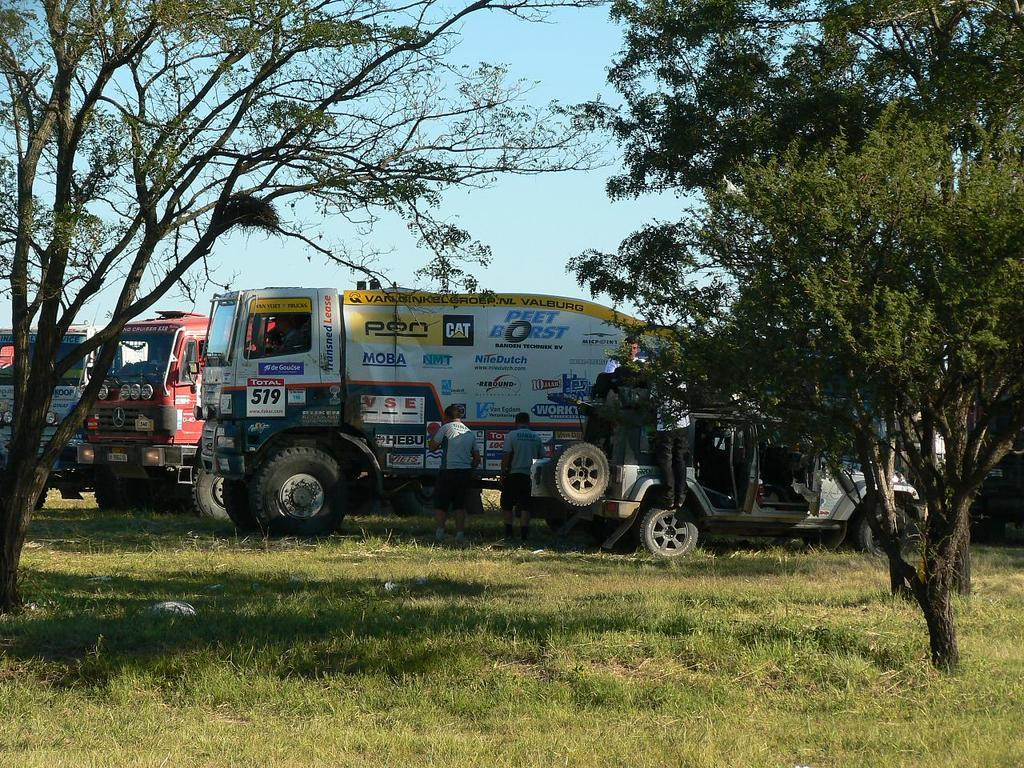What can be seen in the image? There are vehicles in the image. What else is present in the image besides the vehicles? There are people standing near the vehicles and trees in front of the vehicles. What can be seen in the background of the image? The sky is visible in the background of the image. What type of apparatus is being used by the people in the image? There is no apparatus being used by the people in the image; they are simply standing near the vehicles. Can you describe the smiles on the faces of the people in the image? There is no mention of smiles on the faces of the people in the image, as the facts provided do not include any information about their expressions. 